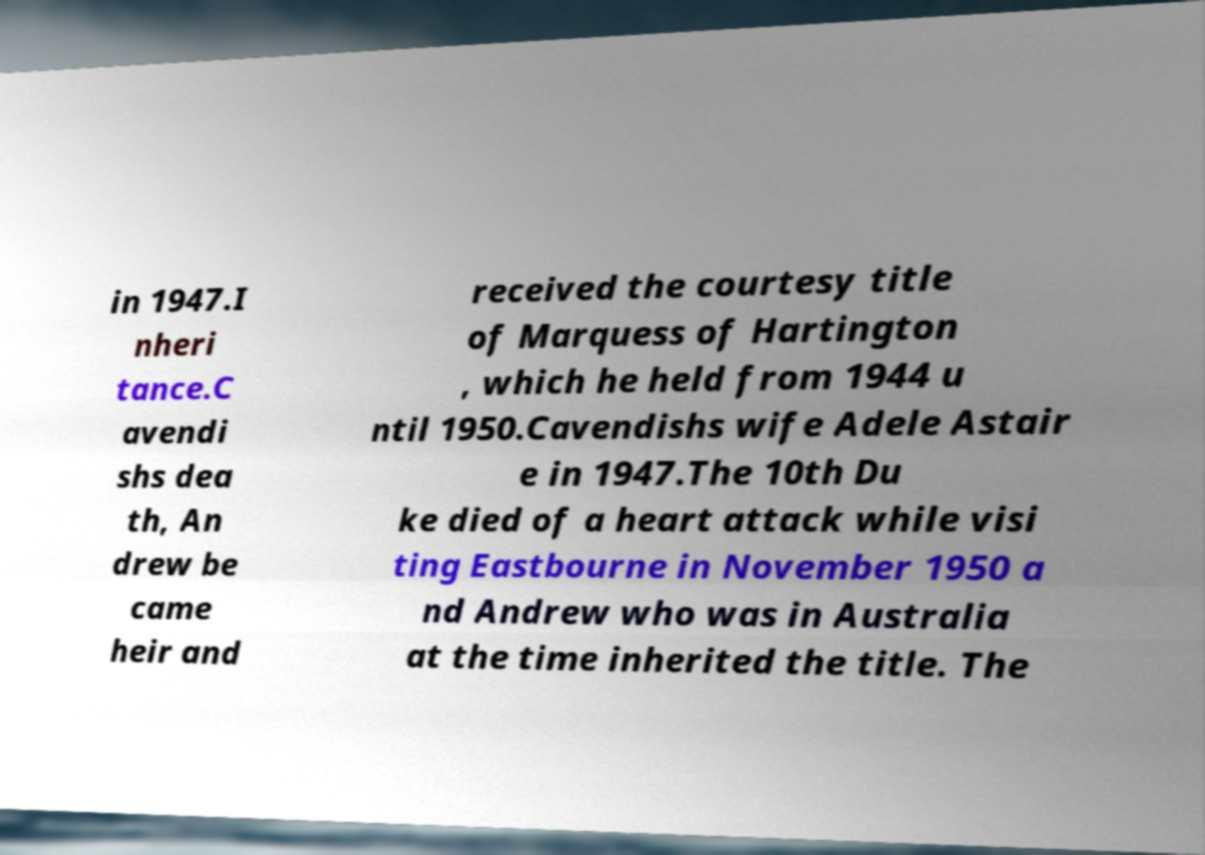What messages or text are displayed in this image? I need them in a readable, typed format. in 1947.I nheri tance.C avendi shs dea th, An drew be came heir and received the courtesy title of Marquess of Hartington , which he held from 1944 u ntil 1950.Cavendishs wife Adele Astair e in 1947.The 10th Du ke died of a heart attack while visi ting Eastbourne in November 1950 a nd Andrew who was in Australia at the time inherited the title. The 